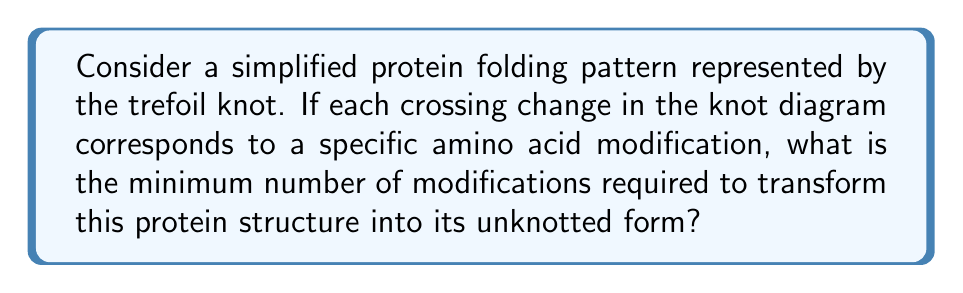Help me with this question. To solve this problem, we need to understand the concept of unknotting number and apply it to the trefoil knot:

1. The unknotting number of a knot is the minimum number of crossing changes required to transform the knot into the unknot (trivial knot).

2. The trefoil knot is one of the simplest non-trivial knots. It has three crossings in its standard diagram.

3. For the trefoil knot, it's known that changing any single crossing is not sufficient to unknot it. This can be verified by checking all three possible single crossing changes.

4. However, changing any two crossings of the trefoil knot will result in the unknot.

5. Therefore, the unknotting number of the trefoil knot is 2.

In the context of protein folding:
- Each crossing in the knot diagram represents a specific fold or interaction in the protein structure.
- A crossing change corresponds to modifying an amino acid or breaking/forming an interaction.
- The unknotting number represents the minimum number of such modifications needed to completely unfold the protein into a linear chain.

Thus, for a protein folding pattern represented by a trefoil knot, at least 2 specific amino acid modifications would be required to transform the structure into its unknotted (unfolded) form.

[asy]
import geometry;

size(100);

path trefoil = (0,1){dir(-60)}..{dir(-120)}(1,-1)..{dir(120)}(-1,-1)..{dir(60)}cycle;
draw(trefoil, blue+1);

label("1", (0.5,0.5));
label("2", (-0.5,0.5));
label("3", (0,-1));
[/asy]
Answer: 2 